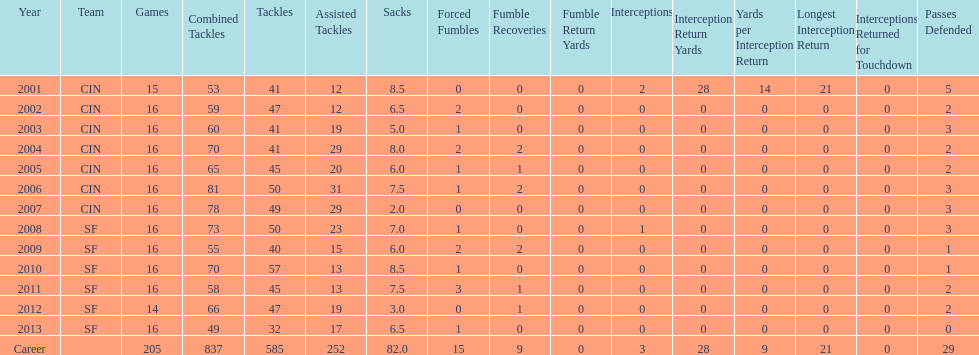How many consecutive seasons has he played sixteen games? 10. 